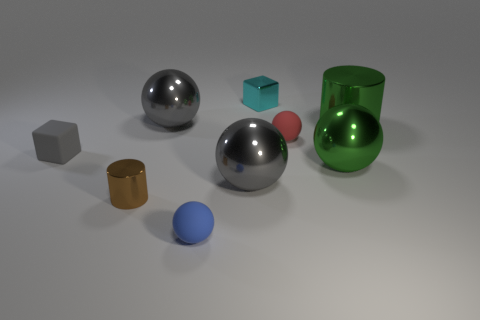The sphere that is the same color as the big shiny cylinder is what size?
Your response must be concise. Large. Are there any blue matte things of the same size as the green cylinder?
Provide a short and direct response. No. There is a small ball behind the shiny cylinder that is to the left of the cyan shiny thing; is there a shiny cylinder that is behind it?
Your answer should be compact. Yes. Do the big cylinder and the rubber object left of the small brown thing have the same color?
Offer a terse response. No. What material is the tiny ball behind the rubber sphere that is to the left of the small metal object behind the tiny red thing made of?
Offer a terse response. Rubber. What is the shape of the small rubber object that is in front of the tiny gray object?
Provide a succinct answer. Sphere. There is a block that is made of the same material as the tiny blue ball; what size is it?
Give a very brief answer. Small. How many brown objects are the same shape as the red matte object?
Offer a terse response. 0. Do the small matte ball that is in front of the gray block and the small metal cylinder have the same color?
Your response must be concise. No. There is a rubber sphere in front of the cylinder left of the big cylinder; what number of large gray objects are behind it?
Ensure brevity in your answer.  2. 